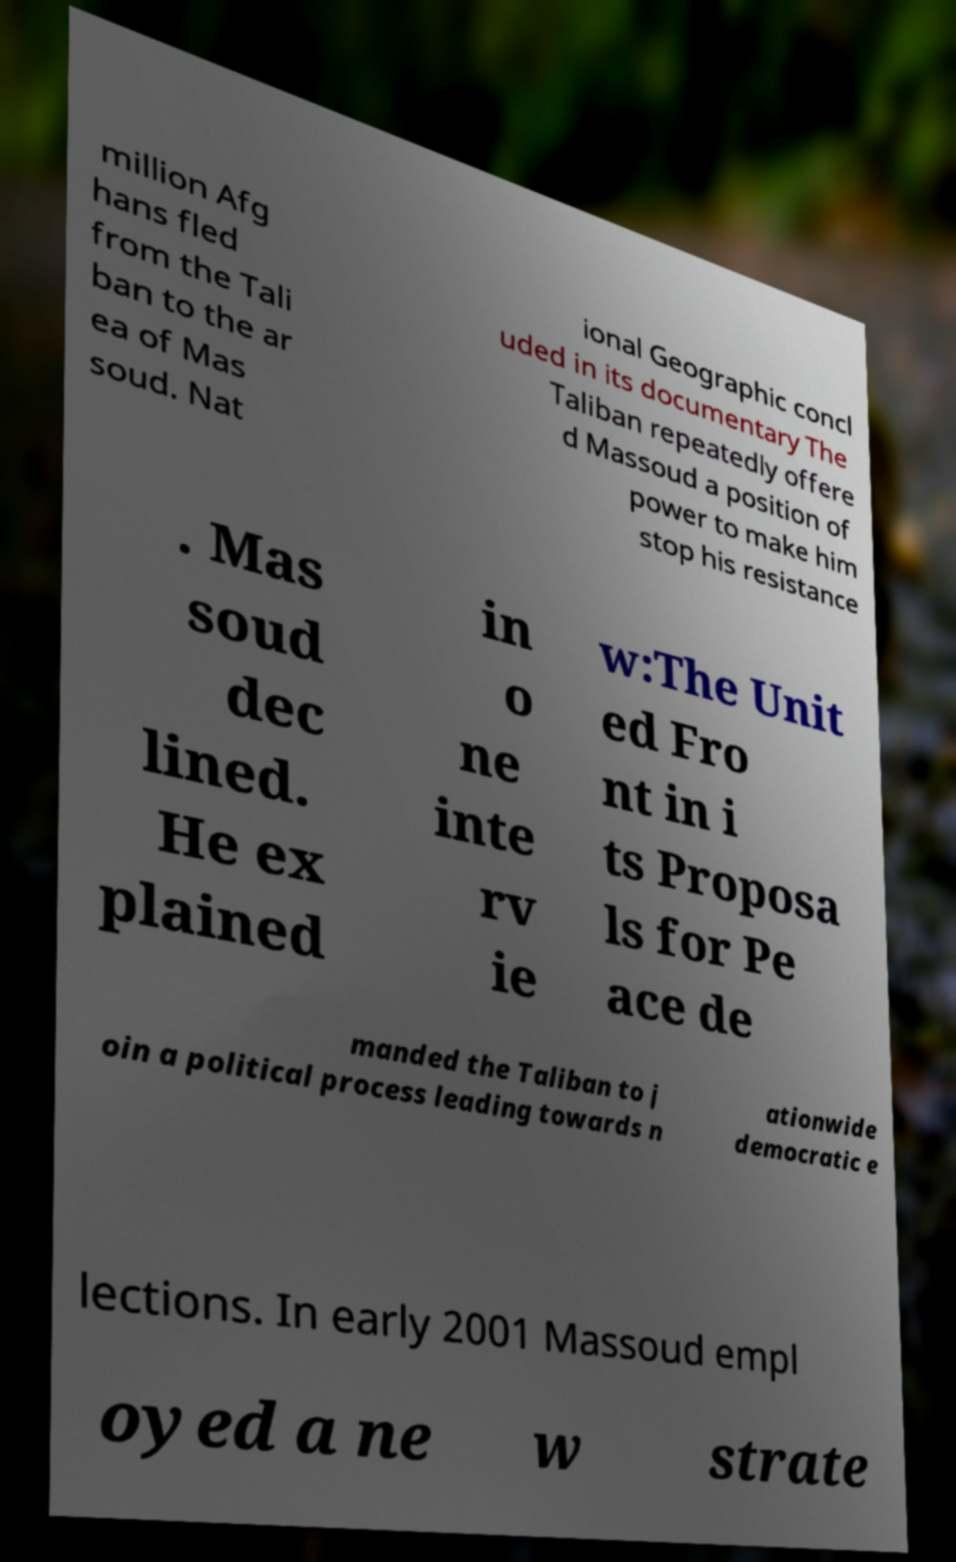Can you accurately transcribe the text from the provided image for me? million Afg hans fled from the Tali ban to the ar ea of Mas soud. Nat ional Geographic concl uded in its documentary The Taliban repeatedly offere d Massoud a position of power to make him stop his resistance . Mas soud dec lined. He ex plained in o ne inte rv ie w:The Unit ed Fro nt in i ts Proposa ls for Pe ace de manded the Taliban to j oin a political process leading towards n ationwide democratic e lections. In early 2001 Massoud empl oyed a ne w strate 